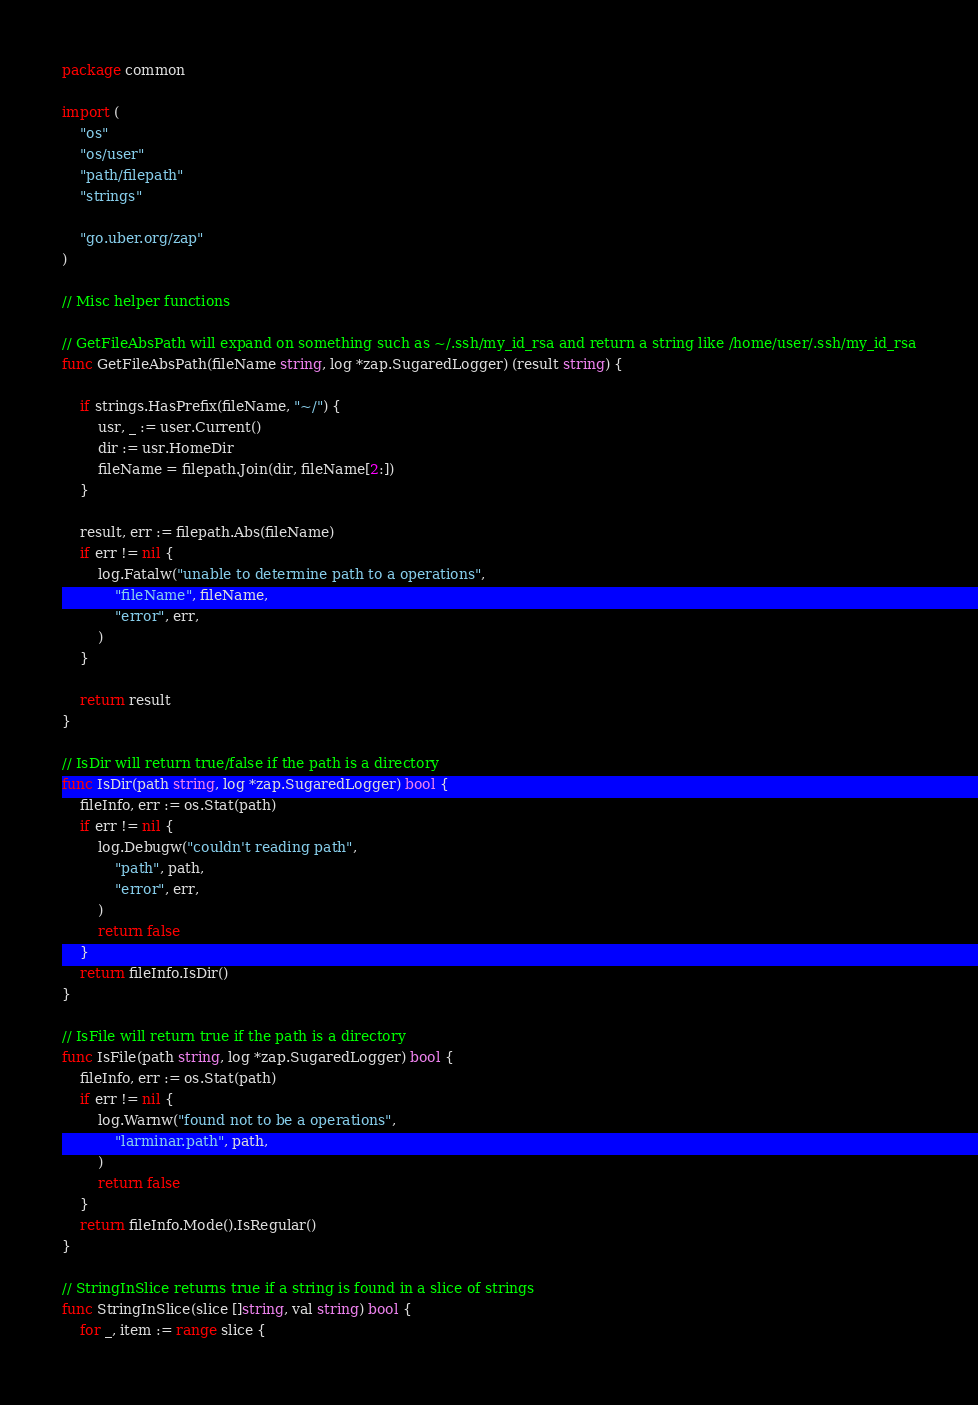Convert code to text. <code><loc_0><loc_0><loc_500><loc_500><_Go_>package common

import (
	"os"
	"os/user"
	"path/filepath"
	"strings"

	"go.uber.org/zap"
)

// Misc helper functions

// GetFileAbsPath will expand on something such as ~/.ssh/my_id_rsa and return a string like /home/user/.ssh/my_id_rsa
func GetFileAbsPath(fileName string, log *zap.SugaredLogger) (result string) {

	if strings.HasPrefix(fileName, "~/") {
		usr, _ := user.Current()
		dir := usr.HomeDir
		fileName = filepath.Join(dir, fileName[2:])
	}

	result, err := filepath.Abs(fileName)
	if err != nil {
		log.Fatalw("unable to determine path to a operations",
			"fileName", fileName,
			"error", err,
		)
	}

	return result
}

// IsDir will return true/false if the path is a directory
func IsDir(path string, log *zap.SugaredLogger) bool {
	fileInfo, err := os.Stat(path)
	if err != nil {
		log.Debugw("couldn't reading path",
			"path", path,
			"error", err,
		)
		return false
	}
	return fileInfo.IsDir()
}

// IsFile will return true if the path is a directory
func IsFile(path string, log *zap.SugaredLogger) bool {
	fileInfo, err := os.Stat(path)
	if err != nil {
		log.Warnw("found not to be a operations",
			"larminar.path", path,
		)
		return false
	}
	return fileInfo.Mode().IsRegular()
}

// StringInSlice returns true if a string is found in a slice of strings
func StringInSlice(slice []string, val string) bool {
	for _, item := range slice {</code> 